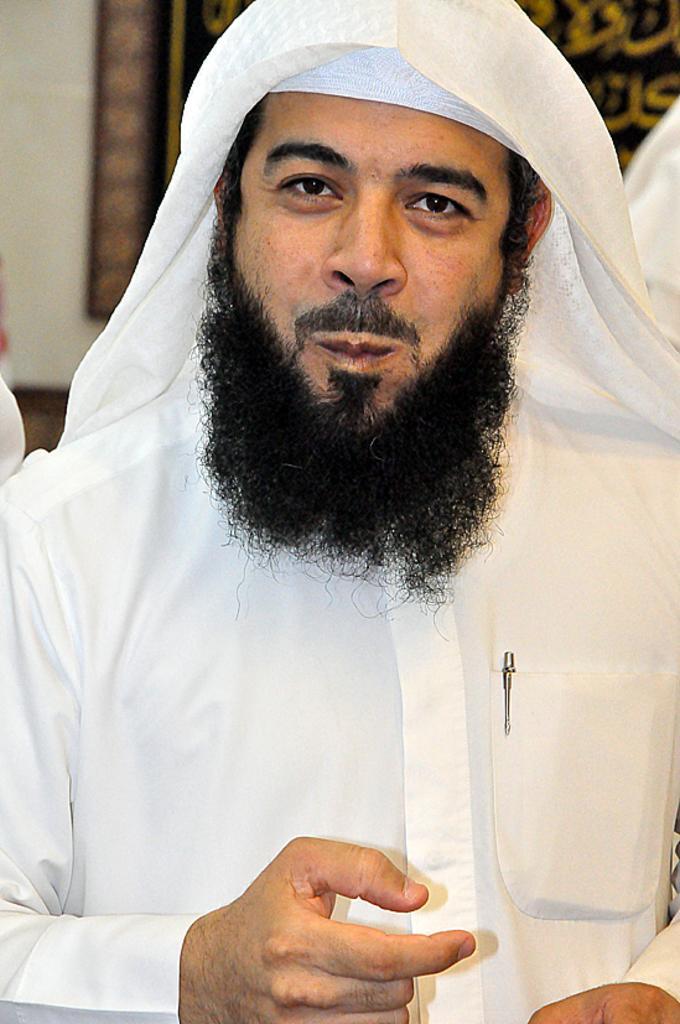Describe this image in one or two sentences. In this picture we can see the man standing in the front, smiling and giving a pose to the camera. Behind there is a black poster on the wall. 